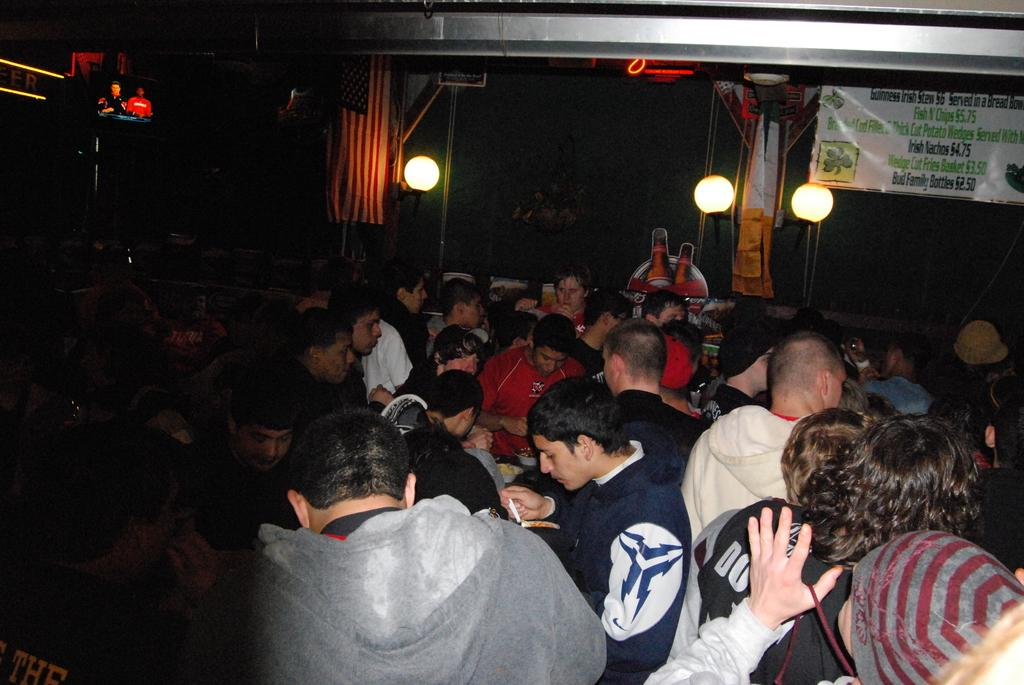How many people are in the image? There is a group of persons in the image, but the exact number cannot be determined from the provided facts. What can be seen at the top of the image? There are lights and hoarding boards visible at the top of the image. What type of card is being used by the person in the image? There is no card present in the image. How low is the ceiling in the room depicted in the image? There is no room or ceiling visible in the image; it only shows a group of persons, lights, and hoarding boards. 